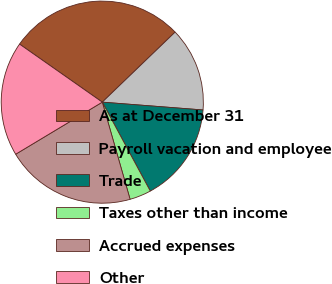<chart> <loc_0><loc_0><loc_500><loc_500><pie_chart><fcel>As at December 31<fcel>Payroll vacation and employee<fcel>Trade<fcel>Taxes other than income<fcel>Accrued expenses<fcel>Other<nl><fcel>28.08%<fcel>13.42%<fcel>15.89%<fcel>3.44%<fcel>20.82%<fcel>18.35%<nl></chart> 